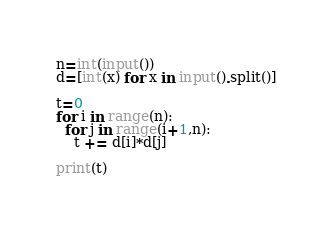<code> <loc_0><loc_0><loc_500><loc_500><_Python_>n=int(input())
d=[int(x) for x in input().split()]

t=0
for i in range(n):
  for j in range(i+1,n):
    t += d[i]*d[j]

print(t)
</code> 